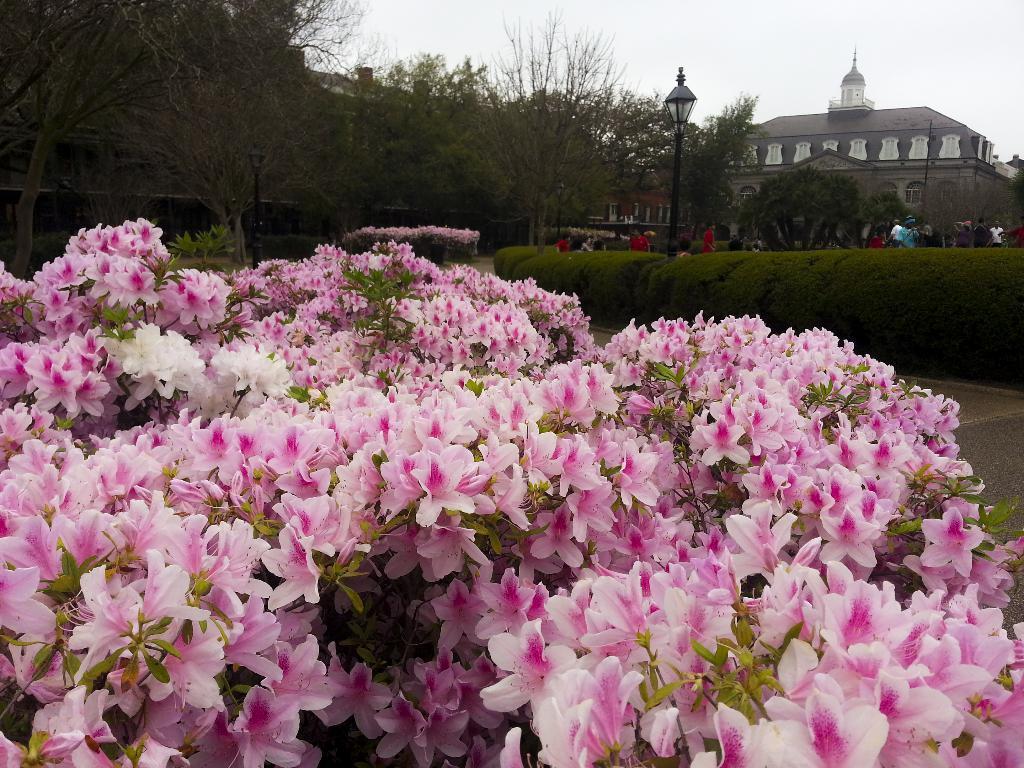In one or two sentences, can you explain what this image depicts? In this picture we can see plants with flowers, some people, light poles, trees, building with windows and in the background we can see the sky. 